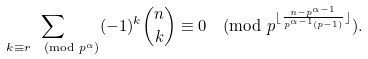Convert formula to latex. <formula><loc_0><loc_0><loc_500><loc_500>\sum _ { k \equiv r \pmod { p ^ { \alpha } } } ( - 1 ) ^ { k } \binom { n } { k } \equiv 0 \pmod { p ^ { \lfloor \frac { n - p ^ { \alpha - 1 } } { p ^ { \alpha - 1 } ( p - 1 ) } \rfloor } } .</formula> 